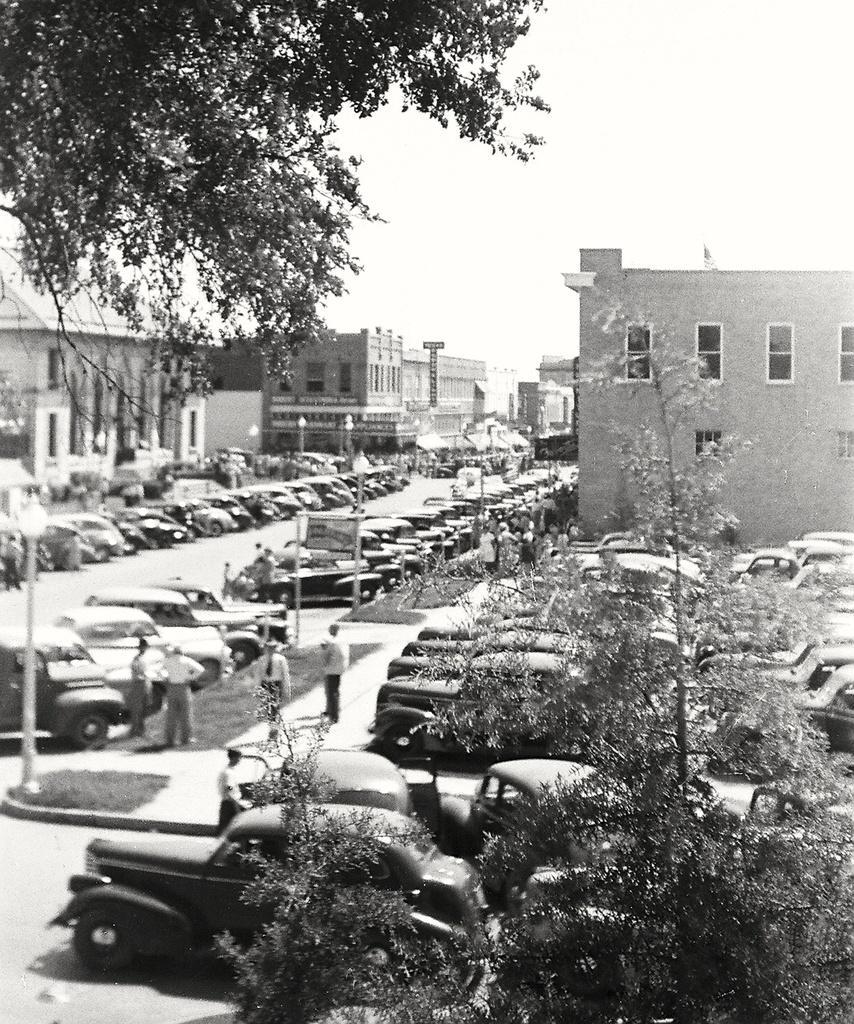Please provide a concise description of this image. This is a black and white image. At the bottom of the image there are cars in the parking area and also there are trees. There are few people standing on the path and also there are poles. And there are few more cars on the roads. In the background there are buildings with walls and windows. In the top left corner of the image there are branches with leaves. 